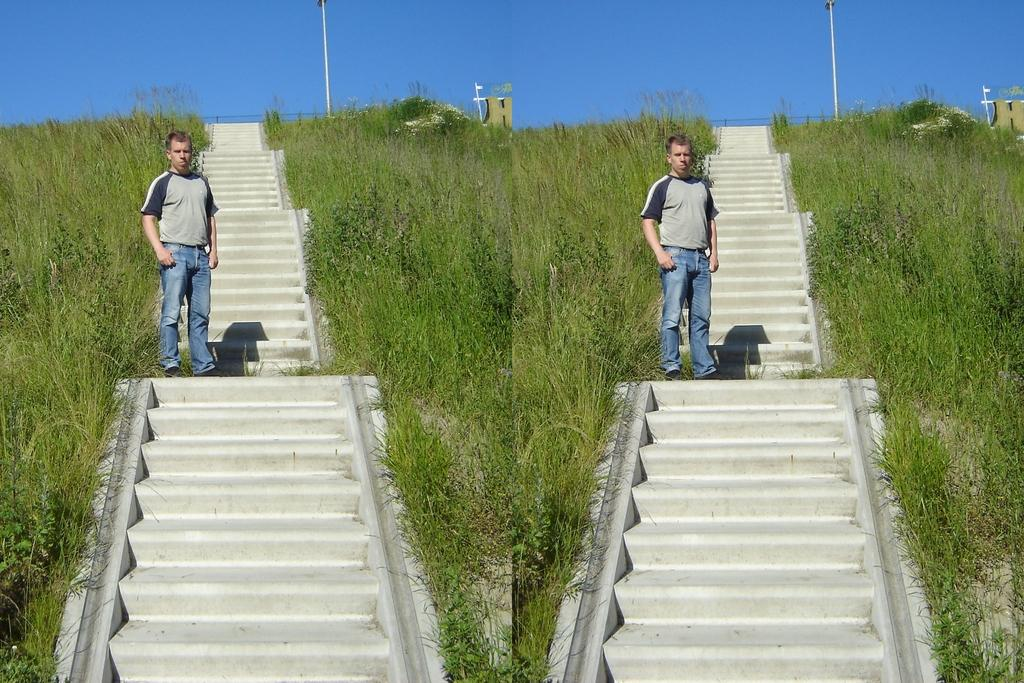What is the man in the image doing? The man is standing on steps in the image. How is the image presented? The image is mirrored. What type of vegetation is near the steps? There is grass beside the steps. What other structures are present in the image? There is a pole and railing in the image. What can be seen in the background of the image? The sky is visible in the image. How many chairs are visible in the image? There are no chairs present in the image. What is the man's desire in the image? The image does not provide information about the man's desires, so it cannot be determined. 